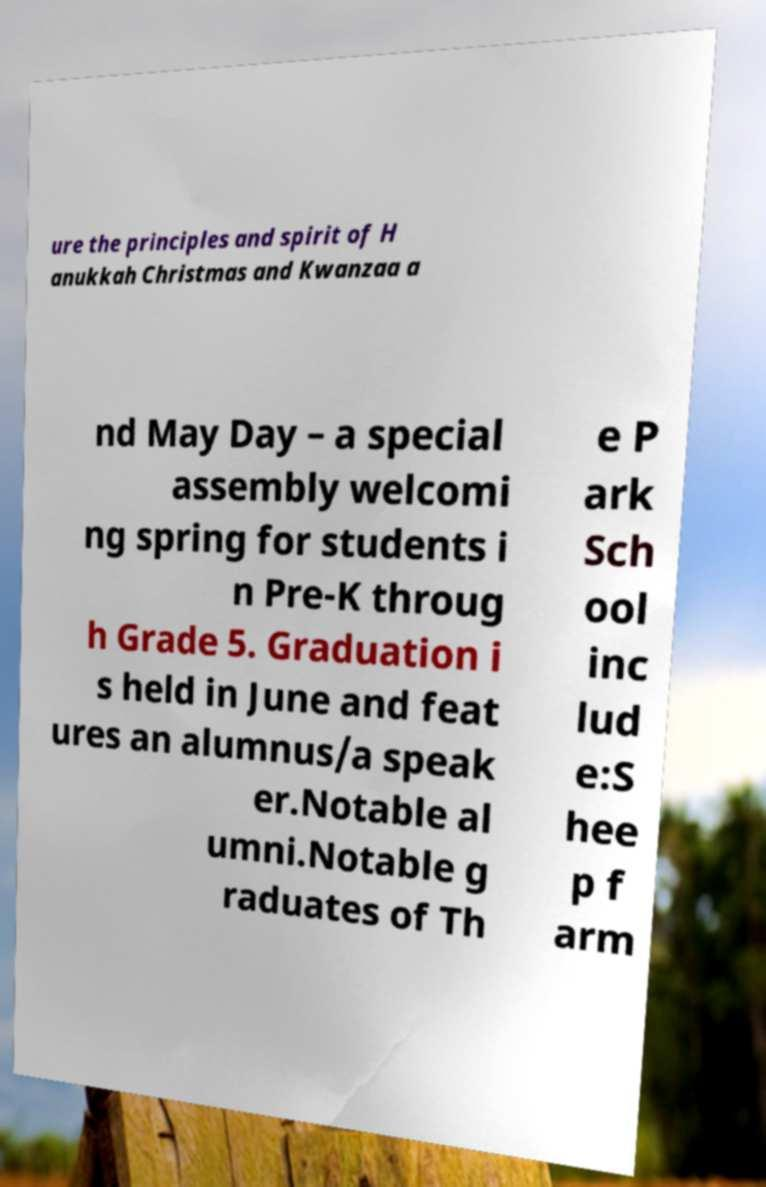Could you extract and type out the text from this image? ure the principles and spirit of H anukkah Christmas and Kwanzaa a nd May Day – a special assembly welcomi ng spring for students i n Pre-K throug h Grade 5. Graduation i s held in June and feat ures an alumnus/a speak er.Notable al umni.Notable g raduates of Th e P ark Sch ool inc lud e:S hee p f arm 